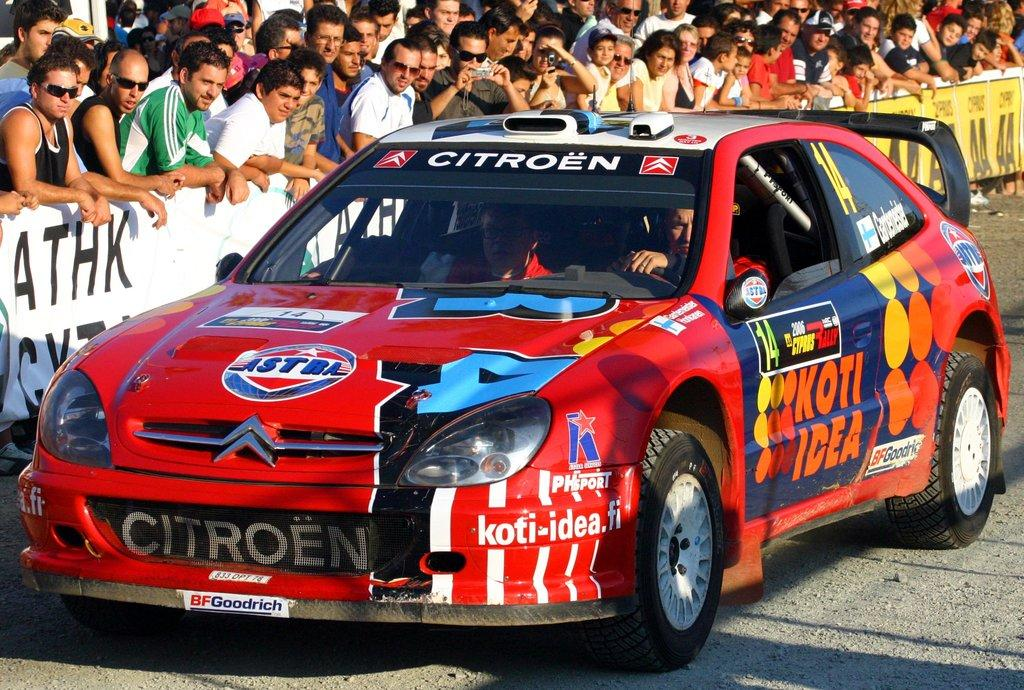What is the main subject of the image? There is a car on the road in the image. Who or what is inside the car? There are people sitting in the car. What can be seen in the background of the image? There is a crowd and a board visible in the background of the image. What type of rod is being used to control the lamp in the image? There is no rod or lamp present in the image. How many chains are visible in the image? There are no chains visible in the image. 